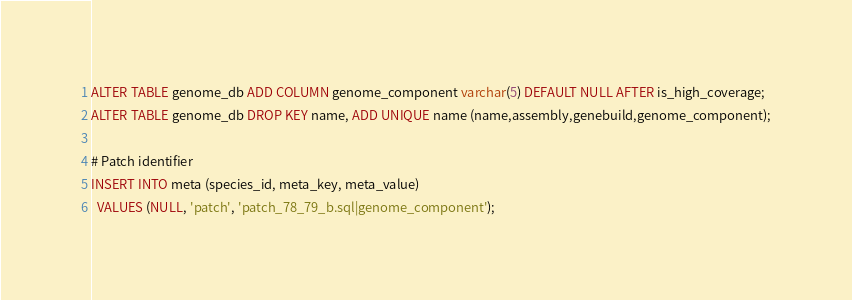Convert code to text. <code><loc_0><loc_0><loc_500><loc_500><_SQL_>
ALTER TABLE genome_db ADD COLUMN genome_component varchar(5) DEFAULT NULL AFTER is_high_coverage;
ALTER TABLE genome_db DROP KEY name, ADD UNIQUE name (name,assembly,genebuild,genome_component);

# Patch identifier
INSERT INTO meta (species_id, meta_key, meta_value)
  VALUES (NULL, 'patch', 'patch_78_79_b.sql|genome_component');
</code> 